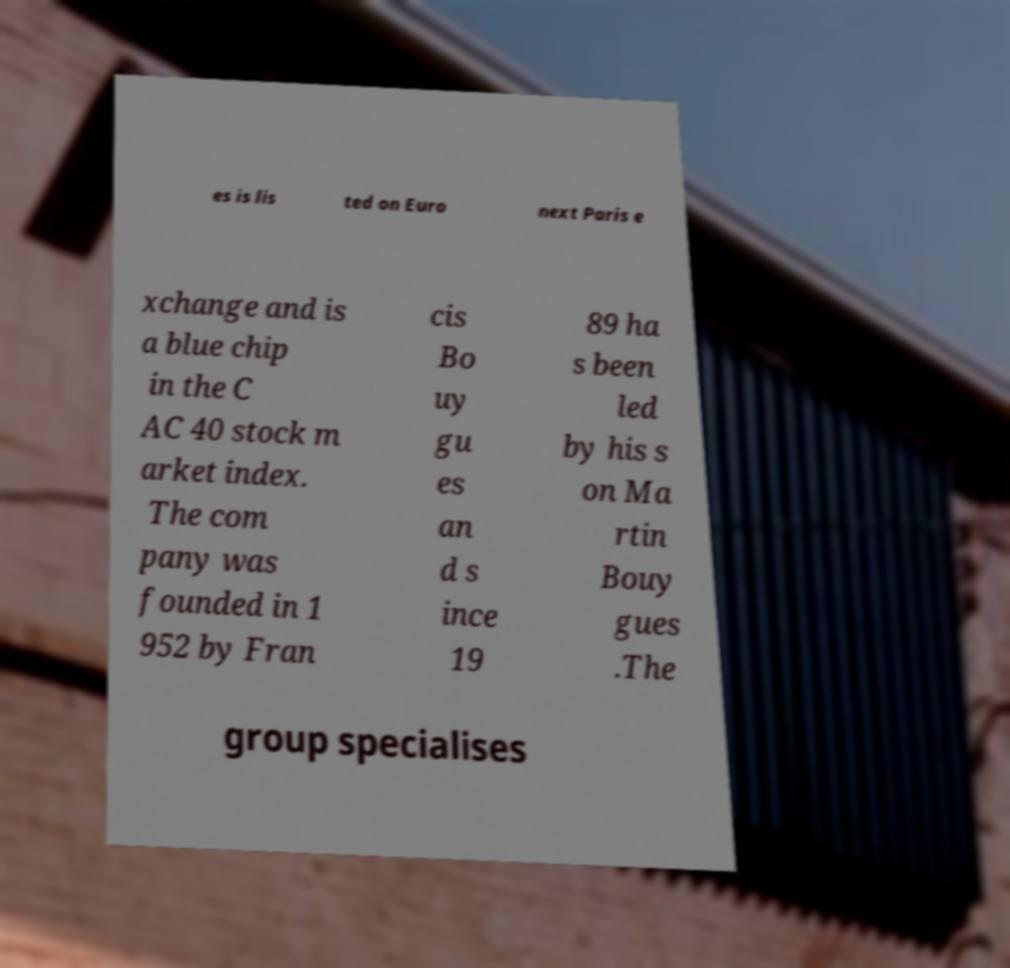Can you read and provide the text displayed in the image?This photo seems to have some interesting text. Can you extract and type it out for me? es is lis ted on Euro next Paris e xchange and is a blue chip in the C AC 40 stock m arket index. The com pany was founded in 1 952 by Fran cis Bo uy gu es an d s ince 19 89 ha s been led by his s on Ma rtin Bouy gues .The group specialises 